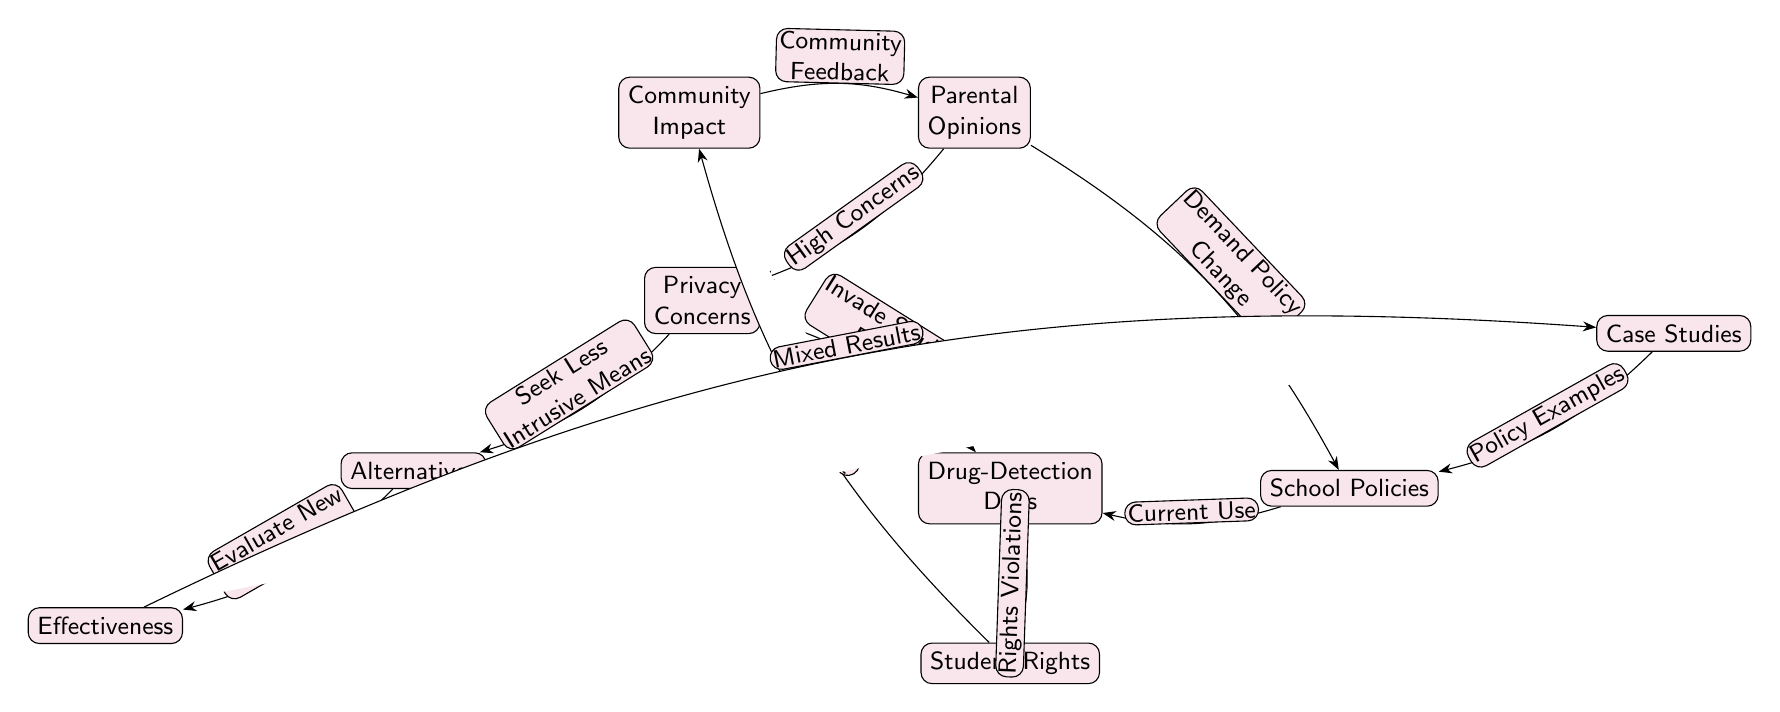What are the two key concerns linked to privacy? The diagram indicates that "Drug-Detection Dogs" and "Alternatives" are both connected to "Privacy Concerns." The direct edges from "Privacy Concerns" lead to these two nodes, highlighting them as linked concerns.
Answer: Drug-Detection Dogs, Alternatives What is the relationship between parental opinions and school policies? The arrow from "Parental Opinions" to "School Policies" indicates a demand for policy change based on parental feelings. It signifies that the opinions held by parents directly influence the decisions schools make regarding policies.
Answer: Demand Policy Change How many nodes are involved in the diagram? Counting all the labeled nodes in the diagram results in a total of nine distinct nodes connected by edges, which encompass all the aspects addressed visually.
Answer: Nine Which node is associated with community impact? The diagram shows that "Community Impact" is related specifically to "Student Rights." This is indicated by the edge leading from "Student Rights" to "Community Impact," illuminating the connection.
Answer: Community Impact What do parents prioritize in terms of alternatives? Parents seem to prioritize "Less Intrusive Means," demonstrated by the labeled edge from "Privacy Concerns" to "Alternatives," suggesting a desire for methods that respect student privacy.
Answer: Less Intrusive Means Which node discusses the effectiveness of alternatives? The node labeled "Effectiveness" is connected to "Alternatives," emphasizing that it is dedicated to evaluating how effective alternative methods are when compared to existing measures.
Answer: Effectiveness What does the case studies node provide information about? The "Case Studies" node is associated with "Policy Examples," suggesting that it provides concrete examples of how alternative methods, particularly case studies, are applied in practice by schools.
Answer: Policy Examples Which concept is emphasized as affecting trust within the community? The edge from "Student Rights" to "Community Impact" highlights that violations of student rights affect the community's trust in schools, indicating a broader social concern stemming from policy implementations.
Answer: Affects Trust 